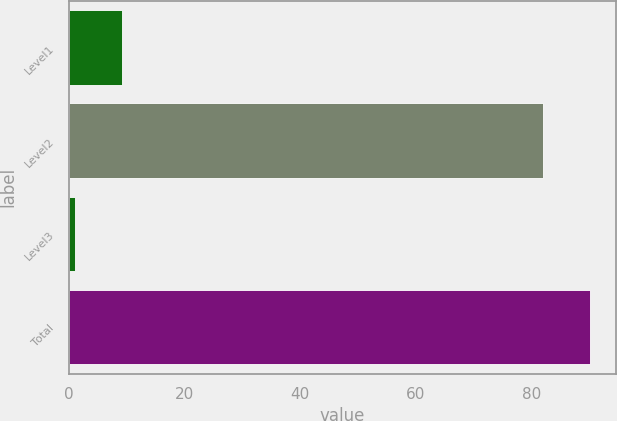<chart> <loc_0><loc_0><loc_500><loc_500><bar_chart><fcel>Level1<fcel>Level2<fcel>Level3<fcel>Total<nl><fcel>9.2<fcel>82<fcel>1<fcel>90.2<nl></chart> 